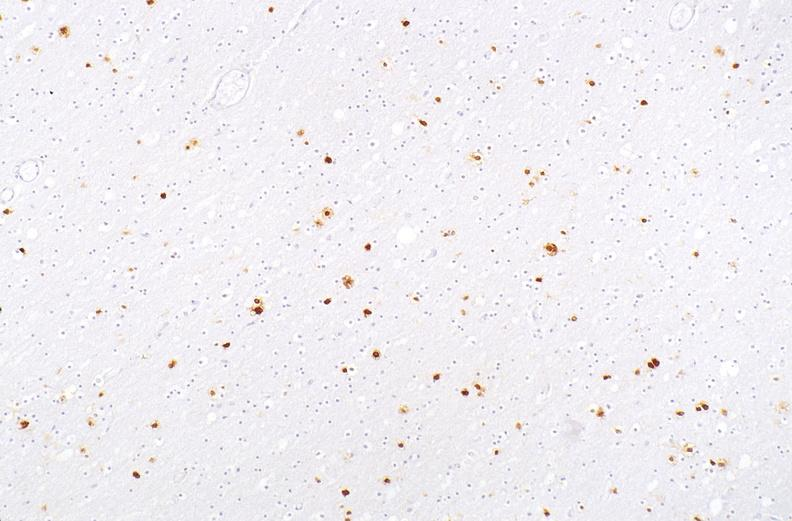s nervous present?
Answer the question using a single word or phrase. Yes 